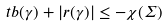<formula> <loc_0><loc_0><loc_500><loc_500>\ t b ( \gamma ) + | r ( \gamma ) | \leq - \chi ( \Sigma )</formula> 